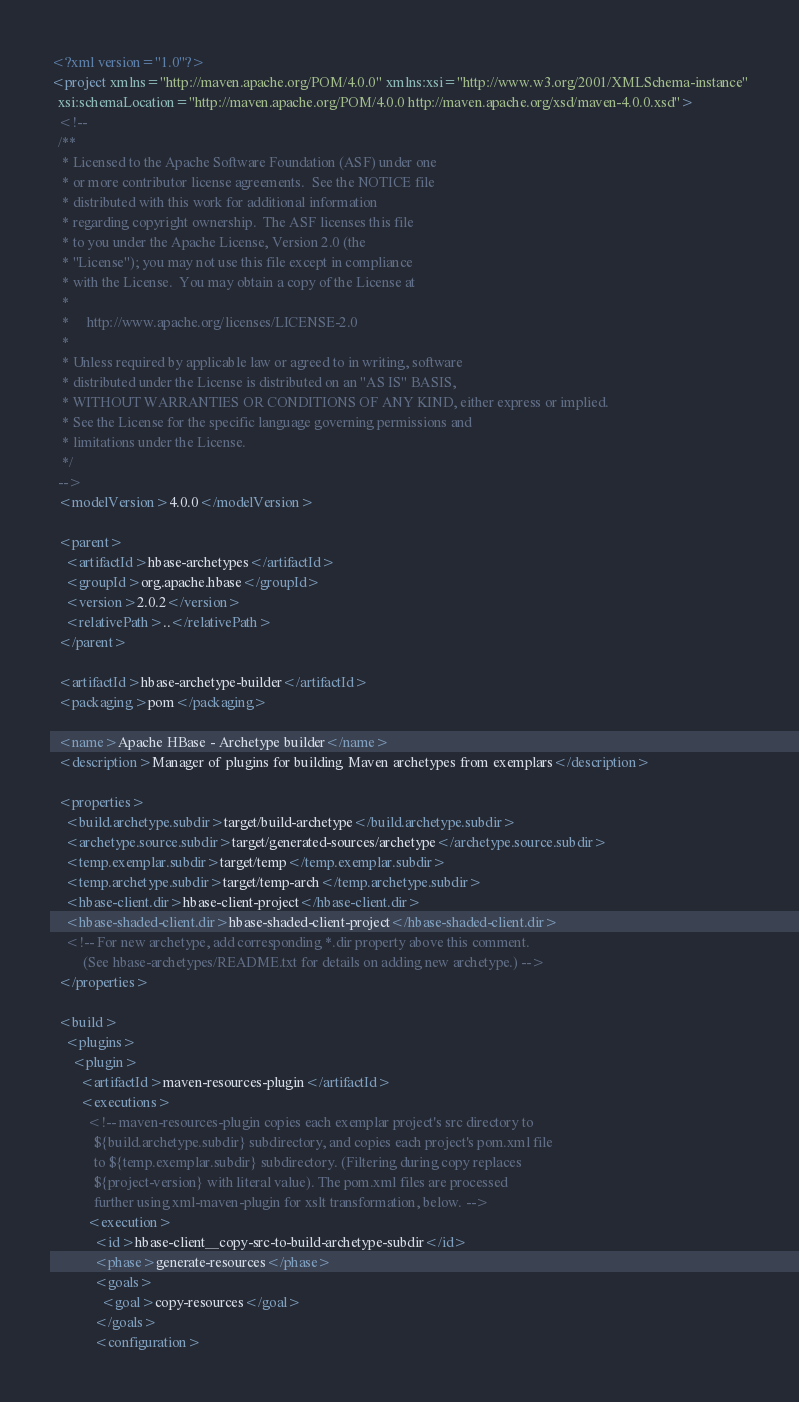<code> <loc_0><loc_0><loc_500><loc_500><_XML_><?xml version="1.0"?>
<project xmlns="http://maven.apache.org/POM/4.0.0" xmlns:xsi="http://www.w3.org/2001/XMLSchema-instance"
  xsi:schemaLocation="http://maven.apache.org/POM/4.0.0 http://maven.apache.org/xsd/maven-4.0.0.xsd">
  <!--
  /**
   * Licensed to the Apache Software Foundation (ASF) under one
   * or more contributor license agreements.  See the NOTICE file
   * distributed with this work for additional information
   * regarding copyright ownership.  The ASF licenses this file
   * to you under the Apache License, Version 2.0 (the
   * "License"); you may not use this file except in compliance
   * with the License.  You may obtain a copy of the License at
   *
   *     http://www.apache.org/licenses/LICENSE-2.0
   *
   * Unless required by applicable law or agreed to in writing, software
   * distributed under the License is distributed on an "AS IS" BASIS,
   * WITHOUT WARRANTIES OR CONDITIONS OF ANY KIND, either express or implied.
   * See the License for the specific language governing permissions and
   * limitations under the License.
   */
  -->
  <modelVersion>4.0.0</modelVersion>

  <parent>
    <artifactId>hbase-archetypes</artifactId>
    <groupId>org.apache.hbase</groupId>
    <version>2.0.2</version>
    <relativePath>..</relativePath>
  </parent>

  <artifactId>hbase-archetype-builder</artifactId>
  <packaging>pom</packaging>

  <name>Apache HBase - Archetype builder</name>
  <description>Manager of plugins for building Maven archetypes from exemplars</description>

  <properties>
    <build.archetype.subdir>target/build-archetype</build.archetype.subdir>
    <archetype.source.subdir>target/generated-sources/archetype</archetype.source.subdir>
    <temp.exemplar.subdir>target/temp</temp.exemplar.subdir>
    <temp.archetype.subdir>target/temp-arch</temp.archetype.subdir>
    <hbase-client.dir>hbase-client-project</hbase-client.dir>
    <hbase-shaded-client.dir>hbase-shaded-client-project</hbase-shaded-client.dir>
    <!-- For new archetype, add corresponding *.dir property above this comment.
         (See hbase-archetypes/README.txt for details on adding new archetype.) -->
  </properties>

  <build>
    <plugins>
      <plugin>
        <artifactId>maven-resources-plugin</artifactId>
        <executions>
          <!-- maven-resources-plugin copies each exemplar project's src directory to
            ${build.archetype.subdir} subdirectory, and copies each project's pom.xml file
            to ${temp.exemplar.subdir} subdirectory. (Filtering during copy replaces
            ${project-version} with literal value). The pom.xml files are processed
            further using xml-maven-plugin for xslt transformation, below. -->
          <execution>
            <id>hbase-client__copy-src-to-build-archetype-subdir</id>
            <phase>generate-resources</phase>
            <goals>
              <goal>copy-resources</goal>
            </goals>
            <configuration></code> 